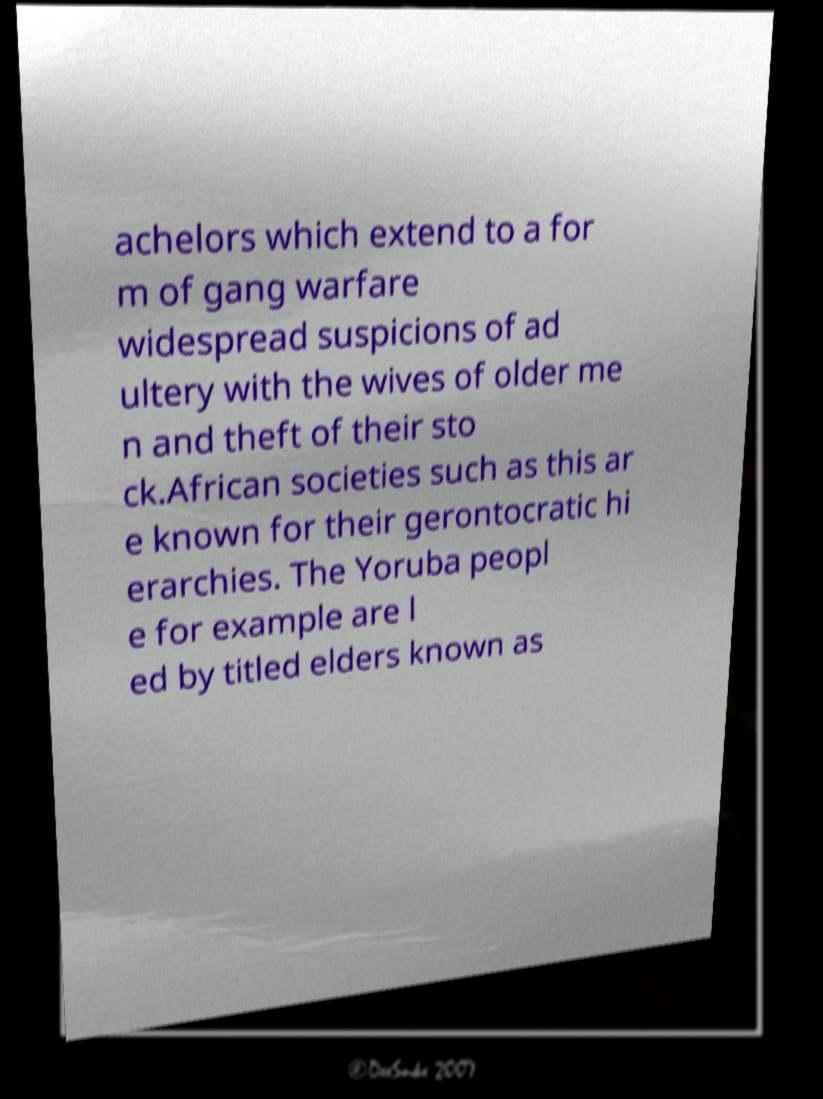Can you read and provide the text displayed in the image?This photo seems to have some interesting text. Can you extract and type it out for me? achelors which extend to a for m of gang warfare widespread suspicions of ad ultery with the wives of older me n and theft of their sto ck.African societies such as this ar e known for their gerontocratic hi erarchies. The Yoruba peopl e for example are l ed by titled elders known as 